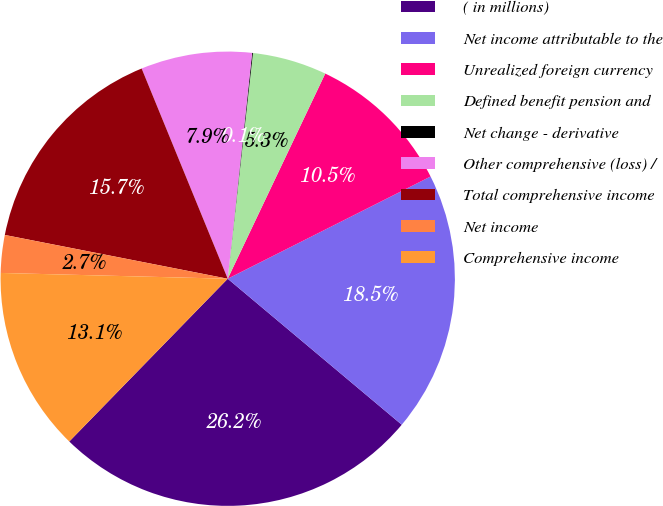Convert chart. <chart><loc_0><loc_0><loc_500><loc_500><pie_chart><fcel>( in millions)<fcel>Net income attributable to the<fcel>Unrealized foreign currency<fcel>Defined benefit pension and<fcel>Net change - derivative<fcel>Other comprehensive (loss) /<fcel>Total comprehensive income<fcel>Net income<fcel>Comprehensive income<nl><fcel>26.18%<fcel>18.54%<fcel>10.51%<fcel>5.29%<fcel>0.06%<fcel>7.9%<fcel>15.73%<fcel>2.68%<fcel>13.12%<nl></chart> 